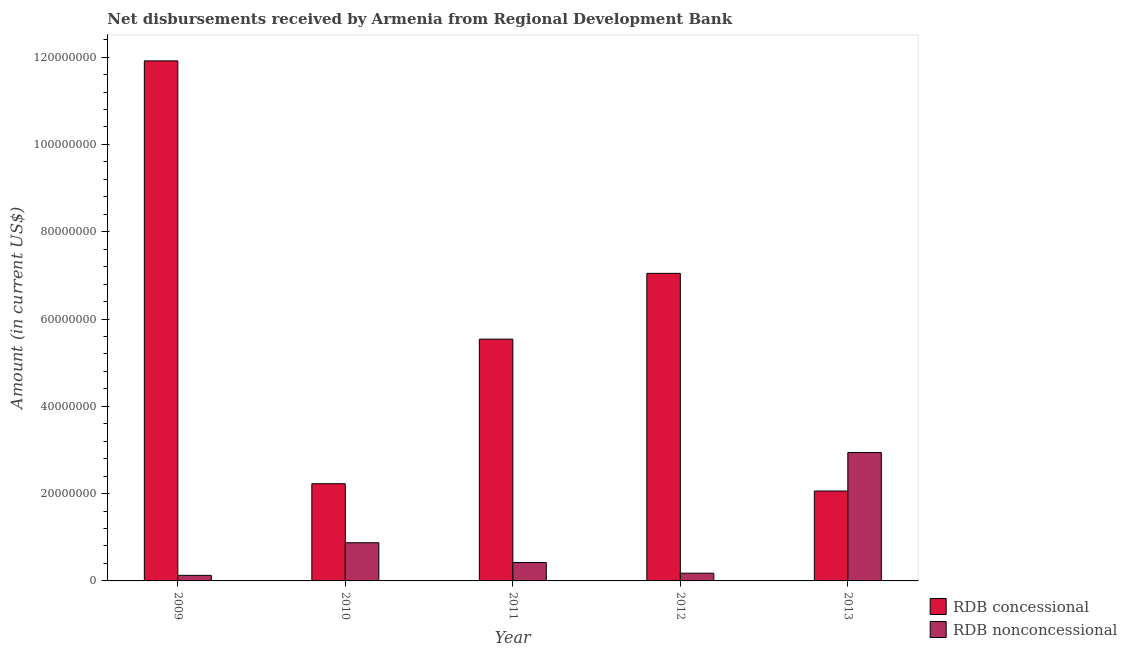How many different coloured bars are there?
Your answer should be compact. 2. How many groups of bars are there?
Offer a terse response. 5. Are the number of bars per tick equal to the number of legend labels?
Keep it short and to the point. Yes. Are the number of bars on each tick of the X-axis equal?
Offer a terse response. Yes. How many bars are there on the 2nd tick from the right?
Your answer should be compact. 2. What is the label of the 3rd group of bars from the left?
Ensure brevity in your answer.  2011. What is the net non concessional disbursements from rdb in 2013?
Ensure brevity in your answer.  2.94e+07. Across all years, what is the maximum net non concessional disbursements from rdb?
Offer a very short reply. 2.94e+07. Across all years, what is the minimum net concessional disbursements from rdb?
Ensure brevity in your answer.  2.06e+07. In which year was the net concessional disbursements from rdb minimum?
Your response must be concise. 2013. What is the total net concessional disbursements from rdb in the graph?
Your answer should be very brief. 2.88e+08. What is the difference between the net concessional disbursements from rdb in 2009 and that in 2013?
Offer a terse response. 9.85e+07. What is the difference between the net concessional disbursements from rdb in 2011 and the net non concessional disbursements from rdb in 2010?
Offer a terse response. 3.31e+07. What is the average net non concessional disbursements from rdb per year?
Give a very brief answer. 9.08e+06. In the year 2012, what is the difference between the net non concessional disbursements from rdb and net concessional disbursements from rdb?
Provide a succinct answer. 0. In how many years, is the net non concessional disbursements from rdb greater than 80000000 US$?
Keep it short and to the point. 0. What is the ratio of the net non concessional disbursements from rdb in 2012 to that in 2013?
Offer a terse response. 0.06. Is the net non concessional disbursements from rdb in 2010 less than that in 2012?
Your answer should be very brief. No. Is the difference between the net non concessional disbursements from rdb in 2012 and 2013 greater than the difference between the net concessional disbursements from rdb in 2012 and 2013?
Provide a succinct answer. No. What is the difference between the highest and the second highest net non concessional disbursements from rdb?
Ensure brevity in your answer.  2.07e+07. What is the difference between the highest and the lowest net concessional disbursements from rdb?
Offer a terse response. 9.85e+07. Is the sum of the net concessional disbursements from rdb in 2010 and 2012 greater than the maximum net non concessional disbursements from rdb across all years?
Keep it short and to the point. No. What does the 1st bar from the left in 2012 represents?
Offer a terse response. RDB concessional. What does the 1st bar from the right in 2010 represents?
Provide a succinct answer. RDB nonconcessional. How many bars are there?
Your answer should be very brief. 10. Are all the bars in the graph horizontal?
Ensure brevity in your answer.  No. How many years are there in the graph?
Provide a succinct answer. 5. Does the graph contain any zero values?
Give a very brief answer. No. Does the graph contain grids?
Your response must be concise. No. What is the title of the graph?
Your response must be concise. Net disbursements received by Armenia from Regional Development Bank. Does "Urban" appear as one of the legend labels in the graph?
Your response must be concise. No. What is the label or title of the Y-axis?
Provide a short and direct response. Amount (in current US$). What is the Amount (in current US$) in RDB concessional in 2009?
Give a very brief answer. 1.19e+08. What is the Amount (in current US$) in RDB nonconcessional in 2009?
Provide a succinct answer. 1.28e+06. What is the Amount (in current US$) of RDB concessional in 2010?
Ensure brevity in your answer.  2.23e+07. What is the Amount (in current US$) in RDB nonconcessional in 2010?
Your answer should be compact. 8.75e+06. What is the Amount (in current US$) of RDB concessional in 2011?
Give a very brief answer. 5.54e+07. What is the Amount (in current US$) of RDB nonconcessional in 2011?
Ensure brevity in your answer.  4.21e+06. What is the Amount (in current US$) in RDB concessional in 2012?
Offer a terse response. 7.05e+07. What is the Amount (in current US$) in RDB nonconcessional in 2012?
Give a very brief answer. 1.77e+06. What is the Amount (in current US$) of RDB concessional in 2013?
Ensure brevity in your answer.  2.06e+07. What is the Amount (in current US$) in RDB nonconcessional in 2013?
Your answer should be compact. 2.94e+07. Across all years, what is the maximum Amount (in current US$) in RDB concessional?
Give a very brief answer. 1.19e+08. Across all years, what is the maximum Amount (in current US$) of RDB nonconcessional?
Offer a very short reply. 2.94e+07. Across all years, what is the minimum Amount (in current US$) of RDB concessional?
Offer a terse response. 2.06e+07. Across all years, what is the minimum Amount (in current US$) in RDB nonconcessional?
Your response must be concise. 1.28e+06. What is the total Amount (in current US$) of RDB concessional in the graph?
Ensure brevity in your answer.  2.88e+08. What is the total Amount (in current US$) in RDB nonconcessional in the graph?
Make the answer very short. 4.54e+07. What is the difference between the Amount (in current US$) in RDB concessional in 2009 and that in 2010?
Make the answer very short. 9.69e+07. What is the difference between the Amount (in current US$) of RDB nonconcessional in 2009 and that in 2010?
Ensure brevity in your answer.  -7.47e+06. What is the difference between the Amount (in current US$) of RDB concessional in 2009 and that in 2011?
Your answer should be very brief. 6.37e+07. What is the difference between the Amount (in current US$) of RDB nonconcessional in 2009 and that in 2011?
Your answer should be very brief. -2.93e+06. What is the difference between the Amount (in current US$) of RDB concessional in 2009 and that in 2012?
Offer a very short reply. 4.87e+07. What is the difference between the Amount (in current US$) in RDB nonconcessional in 2009 and that in 2012?
Your answer should be compact. -4.95e+05. What is the difference between the Amount (in current US$) in RDB concessional in 2009 and that in 2013?
Offer a very short reply. 9.85e+07. What is the difference between the Amount (in current US$) in RDB nonconcessional in 2009 and that in 2013?
Offer a very short reply. -2.81e+07. What is the difference between the Amount (in current US$) of RDB concessional in 2010 and that in 2011?
Give a very brief answer. -3.31e+07. What is the difference between the Amount (in current US$) in RDB nonconcessional in 2010 and that in 2011?
Keep it short and to the point. 4.54e+06. What is the difference between the Amount (in current US$) of RDB concessional in 2010 and that in 2012?
Your response must be concise. -4.82e+07. What is the difference between the Amount (in current US$) in RDB nonconcessional in 2010 and that in 2012?
Give a very brief answer. 6.98e+06. What is the difference between the Amount (in current US$) in RDB concessional in 2010 and that in 2013?
Offer a very short reply. 1.67e+06. What is the difference between the Amount (in current US$) of RDB nonconcessional in 2010 and that in 2013?
Provide a short and direct response. -2.07e+07. What is the difference between the Amount (in current US$) in RDB concessional in 2011 and that in 2012?
Your response must be concise. -1.51e+07. What is the difference between the Amount (in current US$) in RDB nonconcessional in 2011 and that in 2012?
Make the answer very short. 2.44e+06. What is the difference between the Amount (in current US$) in RDB concessional in 2011 and that in 2013?
Make the answer very short. 3.48e+07. What is the difference between the Amount (in current US$) in RDB nonconcessional in 2011 and that in 2013?
Your answer should be very brief. -2.52e+07. What is the difference between the Amount (in current US$) in RDB concessional in 2012 and that in 2013?
Your answer should be very brief. 4.99e+07. What is the difference between the Amount (in current US$) in RDB nonconcessional in 2012 and that in 2013?
Provide a succinct answer. -2.76e+07. What is the difference between the Amount (in current US$) of RDB concessional in 2009 and the Amount (in current US$) of RDB nonconcessional in 2010?
Make the answer very short. 1.10e+08. What is the difference between the Amount (in current US$) in RDB concessional in 2009 and the Amount (in current US$) in RDB nonconcessional in 2011?
Your response must be concise. 1.15e+08. What is the difference between the Amount (in current US$) of RDB concessional in 2009 and the Amount (in current US$) of RDB nonconcessional in 2012?
Offer a terse response. 1.17e+08. What is the difference between the Amount (in current US$) of RDB concessional in 2009 and the Amount (in current US$) of RDB nonconcessional in 2013?
Your answer should be very brief. 8.97e+07. What is the difference between the Amount (in current US$) in RDB concessional in 2010 and the Amount (in current US$) in RDB nonconcessional in 2011?
Make the answer very short. 1.81e+07. What is the difference between the Amount (in current US$) of RDB concessional in 2010 and the Amount (in current US$) of RDB nonconcessional in 2012?
Keep it short and to the point. 2.05e+07. What is the difference between the Amount (in current US$) in RDB concessional in 2010 and the Amount (in current US$) in RDB nonconcessional in 2013?
Provide a succinct answer. -7.15e+06. What is the difference between the Amount (in current US$) of RDB concessional in 2011 and the Amount (in current US$) of RDB nonconcessional in 2012?
Make the answer very short. 5.36e+07. What is the difference between the Amount (in current US$) in RDB concessional in 2011 and the Amount (in current US$) in RDB nonconcessional in 2013?
Give a very brief answer. 2.60e+07. What is the difference between the Amount (in current US$) of RDB concessional in 2012 and the Amount (in current US$) of RDB nonconcessional in 2013?
Your answer should be compact. 4.10e+07. What is the average Amount (in current US$) of RDB concessional per year?
Offer a terse response. 5.76e+07. What is the average Amount (in current US$) in RDB nonconcessional per year?
Your answer should be very brief. 9.08e+06. In the year 2009, what is the difference between the Amount (in current US$) in RDB concessional and Amount (in current US$) in RDB nonconcessional?
Make the answer very short. 1.18e+08. In the year 2010, what is the difference between the Amount (in current US$) of RDB concessional and Amount (in current US$) of RDB nonconcessional?
Provide a succinct answer. 1.35e+07. In the year 2011, what is the difference between the Amount (in current US$) of RDB concessional and Amount (in current US$) of RDB nonconcessional?
Keep it short and to the point. 5.12e+07. In the year 2012, what is the difference between the Amount (in current US$) in RDB concessional and Amount (in current US$) in RDB nonconcessional?
Ensure brevity in your answer.  6.87e+07. In the year 2013, what is the difference between the Amount (in current US$) of RDB concessional and Amount (in current US$) of RDB nonconcessional?
Your answer should be very brief. -8.82e+06. What is the ratio of the Amount (in current US$) in RDB concessional in 2009 to that in 2010?
Make the answer very short. 5.35. What is the ratio of the Amount (in current US$) of RDB nonconcessional in 2009 to that in 2010?
Give a very brief answer. 0.15. What is the ratio of the Amount (in current US$) in RDB concessional in 2009 to that in 2011?
Provide a succinct answer. 2.15. What is the ratio of the Amount (in current US$) of RDB nonconcessional in 2009 to that in 2011?
Your answer should be compact. 0.3. What is the ratio of the Amount (in current US$) in RDB concessional in 2009 to that in 2012?
Provide a short and direct response. 1.69. What is the ratio of the Amount (in current US$) of RDB nonconcessional in 2009 to that in 2012?
Make the answer very short. 0.72. What is the ratio of the Amount (in current US$) in RDB concessional in 2009 to that in 2013?
Offer a very short reply. 5.79. What is the ratio of the Amount (in current US$) of RDB nonconcessional in 2009 to that in 2013?
Offer a very short reply. 0.04. What is the ratio of the Amount (in current US$) of RDB concessional in 2010 to that in 2011?
Provide a short and direct response. 0.4. What is the ratio of the Amount (in current US$) of RDB nonconcessional in 2010 to that in 2011?
Provide a short and direct response. 2.08. What is the ratio of the Amount (in current US$) of RDB concessional in 2010 to that in 2012?
Your answer should be very brief. 0.32. What is the ratio of the Amount (in current US$) in RDB nonconcessional in 2010 to that in 2012?
Keep it short and to the point. 4.94. What is the ratio of the Amount (in current US$) of RDB concessional in 2010 to that in 2013?
Offer a terse response. 1.08. What is the ratio of the Amount (in current US$) of RDB nonconcessional in 2010 to that in 2013?
Ensure brevity in your answer.  0.3. What is the ratio of the Amount (in current US$) in RDB concessional in 2011 to that in 2012?
Make the answer very short. 0.79. What is the ratio of the Amount (in current US$) of RDB nonconcessional in 2011 to that in 2012?
Provide a succinct answer. 2.38. What is the ratio of the Amount (in current US$) in RDB concessional in 2011 to that in 2013?
Keep it short and to the point. 2.69. What is the ratio of the Amount (in current US$) of RDB nonconcessional in 2011 to that in 2013?
Offer a very short reply. 0.14. What is the ratio of the Amount (in current US$) in RDB concessional in 2012 to that in 2013?
Keep it short and to the point. 3.42. What is the ratio of the Amount (in current US$) of RDB nonconcessional in 2012 to that in 2013?
Offer a terse response. 0.06. What is the difference between the highest and the second highest Amount (in current US$) in RDB concessional?
Your response must be concise. 4.87e+07. What is the difference between the highest and the second highest Amount (in current US$) in RDB nonconcessional?
Ensure brevity in your answer.  2.07e+07. What is the difference between the highest and the lowest Amount (in current US$) in RDB concessional?
Ensure brevity in your answer.  9.85e+07. What is the difference between the highest and the lowest Amount (in current US$) of RDB nonconcessional?
Ensure brevity in your answer.  2.81e+07. 